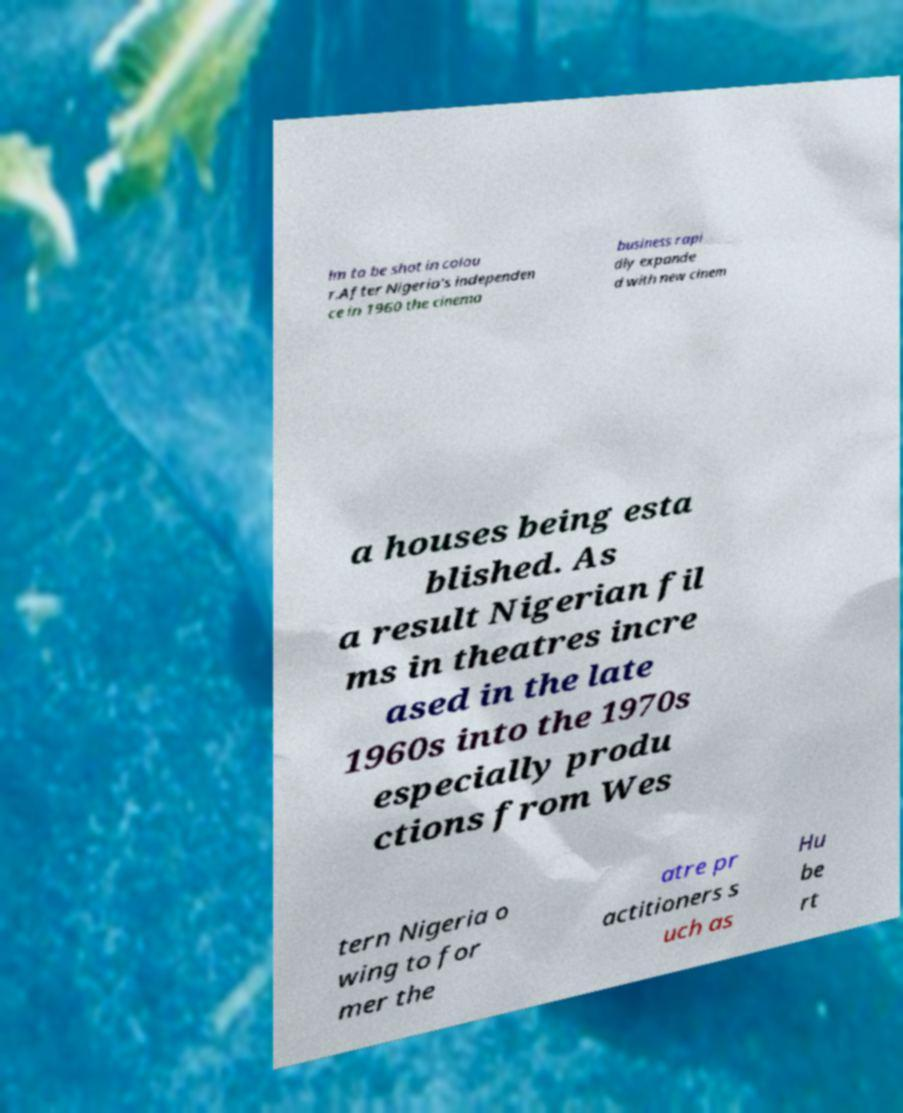Could you extract and type out the text from this image? lm to be shot in colou r.After Nigeria's independen ce in 1960 the cinema business rapi dly expande d with new cinem a houses being esta blished. As a result Nigerian fil ms in theatres incre ased in the late 1960s into the 1970s especially produ ctions from Wes tern Nigeria o wing to for mer the atre pr actitioners s uch as Hu be rt 